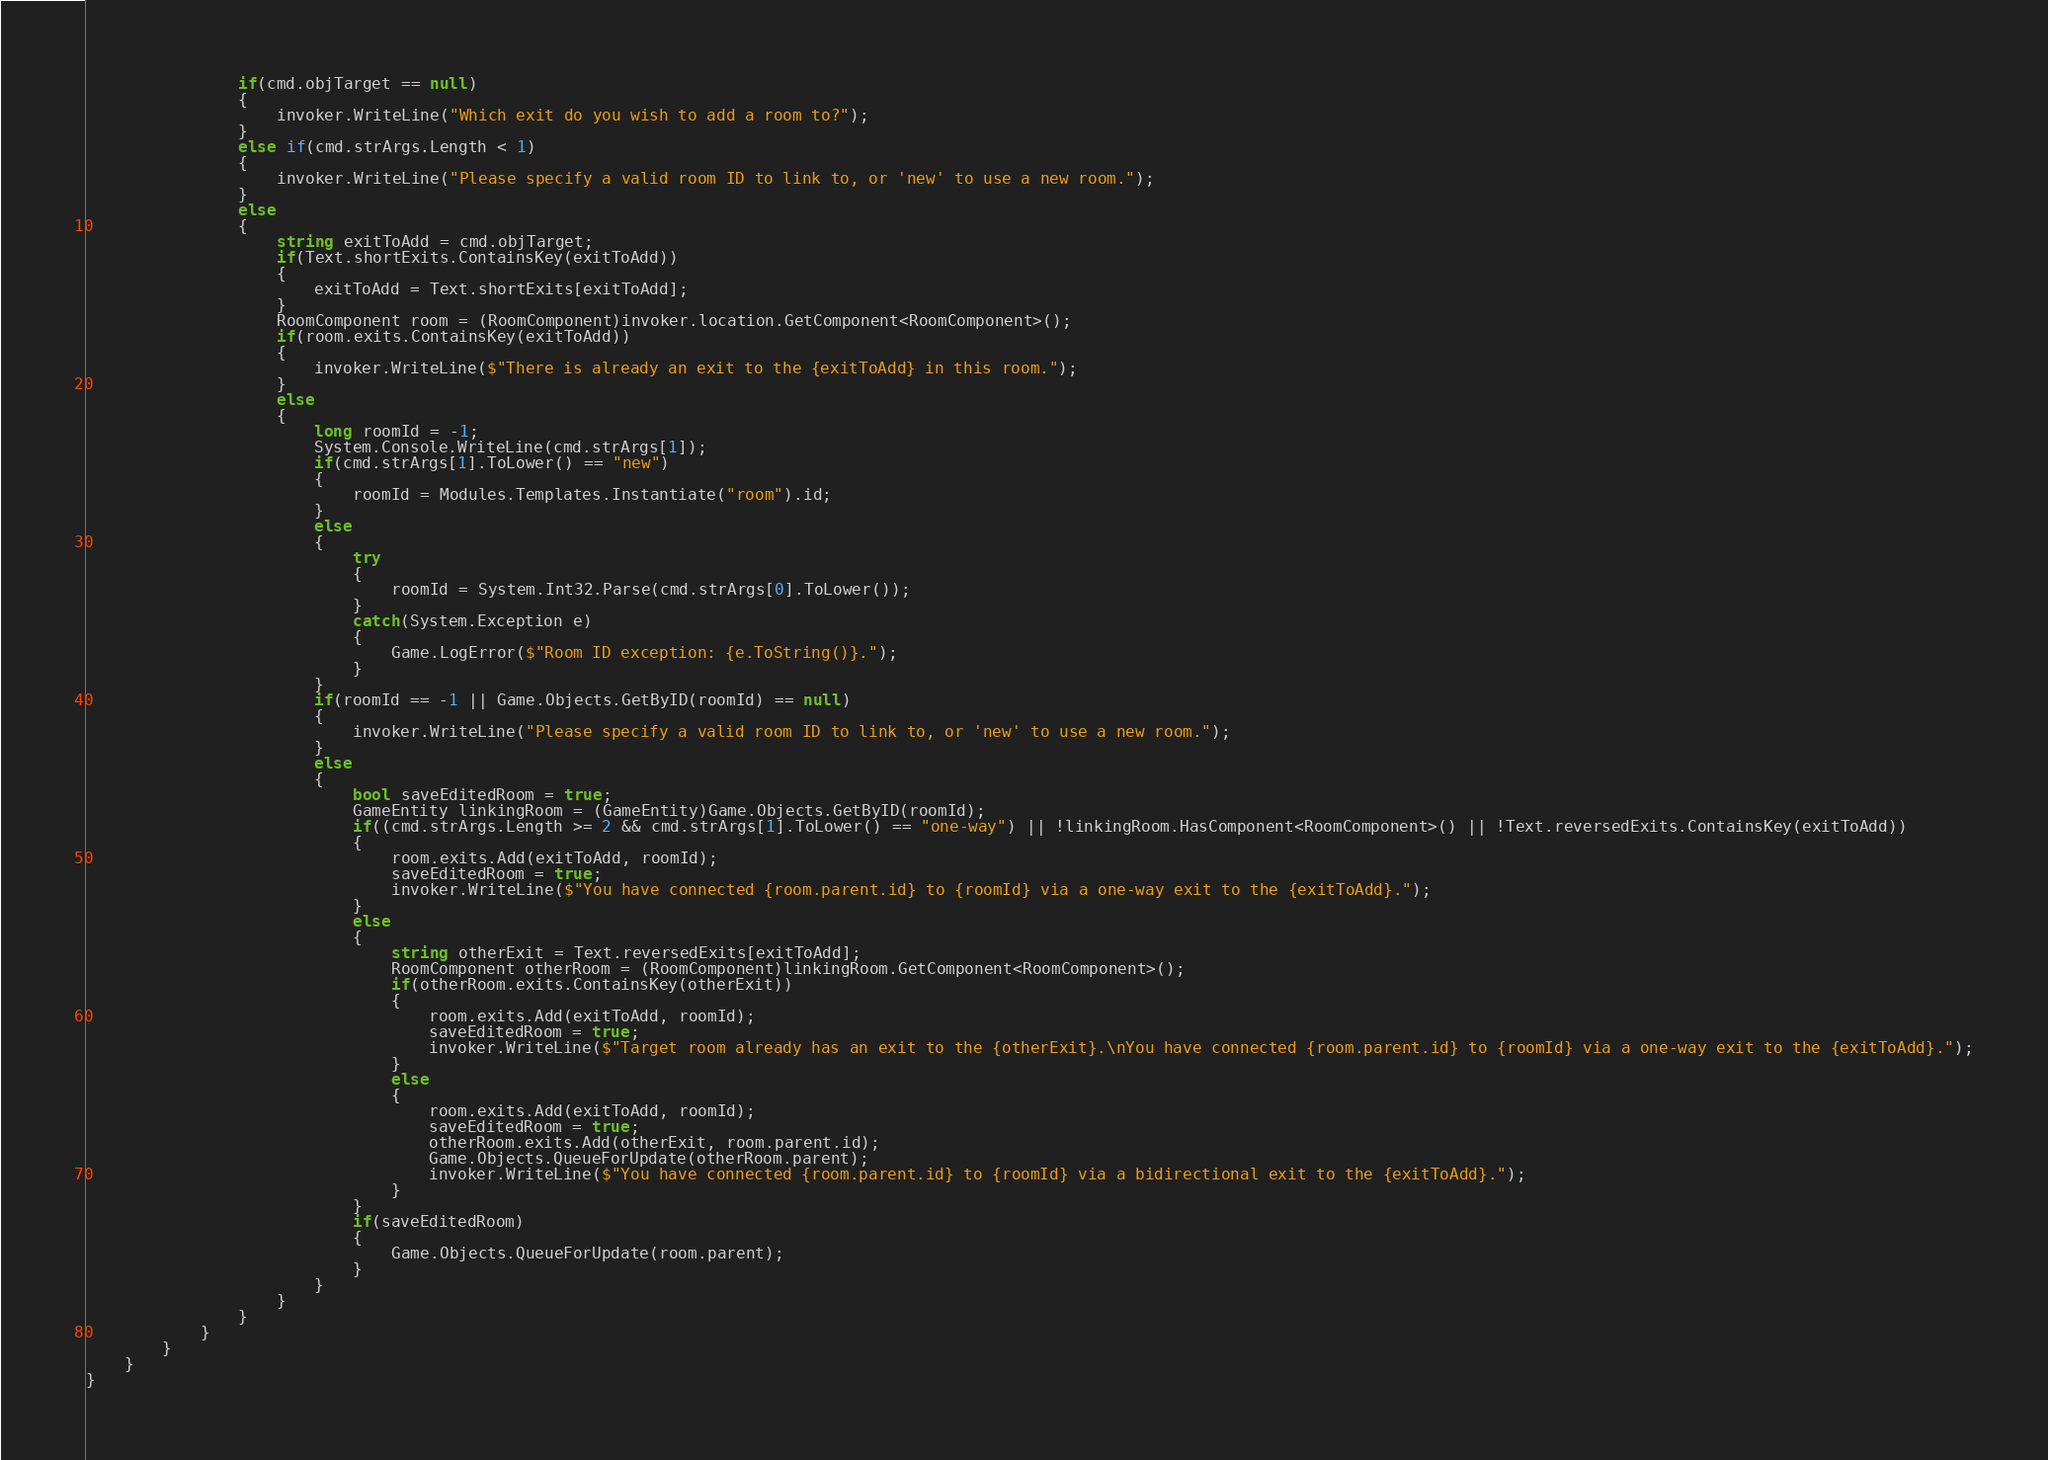<code> <loc_0><loc_0><loc_500><loc_500><_C#_>				if(cmd.objTarget == null)
				{
					invoker.WriteLine("Which exit do you wish to add a room to?");
				}
				else if(cmd.strArgs.Length < 1)
				{
					invoker.WriteLine("Please specify a valid room ID to link to, or 'new' to use a new room.");
				}
				else
				{
					string exitToAdd = cmd.objTarget;
					if(Text.shortExits.ContainsKey(exitToAdd))
					{
						exitToAdd = Text.shortExits[exitToAdd];
					}
					RoomComponent room = (RoomComponent)invoker.location.GetComponent<RoomComponent>();
					if(room.exits.ContainsKey(exitToAdd))
					{
						invoker.WriteLine($"There is already an exit to the {exitToAdd} in this room.");
					}
					else
					{
						long roomId = -1;
						System.Console.WriteLine(cmd.strArgs[1]);
						if(cmd.strArgs[1].ToLower() == "new")
						{
							roomId = Modules.Templates.Instantiate("room").id;
						}
						else
						{
							try
							{
								roomId = System.Int32.Parse(cmd.strArgs[0].ToLower());
							}
							catch(System.Exception e)
							{
								Game.LogError($"Room ID exception: {e.ToString()}.");
							}
						}
						if(roomId == -1 || Game.Objects.GetByID(roomId) == null)
						{
							invoker.WriteLine("Please specify a valid room ID to link to, or 'new' to use a new room.");
						}
						else
						{
							bool saveEditedRoom = true;
							GameEntity linkingRoom = (GameEntity)Game.Objects.GetByID(roomId);
							if((cmd.strArgs.Length >= 2 && cmd.strArgs[1].ToLower() == "one-way") || !linkingRoom.HasComponent<RoomComponent>() || !Text.reversedExits.ContainsKey(exitToAdd))
							{
								room.exits.Add(exitToAdd, roomId);
								saveEditedRoom = true;
								invoker.WriteLine($"You have connected {room.parent.id} to {roomId} via a one-way exit to the {exitToAdd}.");
							}
							else
							{
								string otherExit = Text.reversedExits[exitToAdd];
								RoomComponent otherRoom = (RoomComponent)linkingRoom.GetComponent<RoomComponent>();
								if(otherRoom.exits.ContainsKey(otherExit))
								{
									room.exits.Add(exitToAdd, roomId);
									saveEditedRoom = true;
									invoker.WriteLine($"Target room already has an exit to the {otherExit}.\nYou have connected {room.parent.id} to {roomId} via a one-way exit to the {exitToAdd}.");
								}
								else
								{
									room.exits.Add(exitToAdd, roomId);
									saveEditedRoom = true;
									otherRoom.exits.Add(otherExit, room.parent.id);
									Game.Objects.QueueForUpdate(otherRoom.parent);
									invoker.WriteLine($"You have connected {room.parent.id} to {roomId} via a bidirectional exit to the {exitToAdd}.");
								}
							}
							if(saveEditedRoom)
							{
								Game.Objects.QueueForUpdate(room.parent);
							}
						}
					}
				}
			}
		}
	}
}</code> 